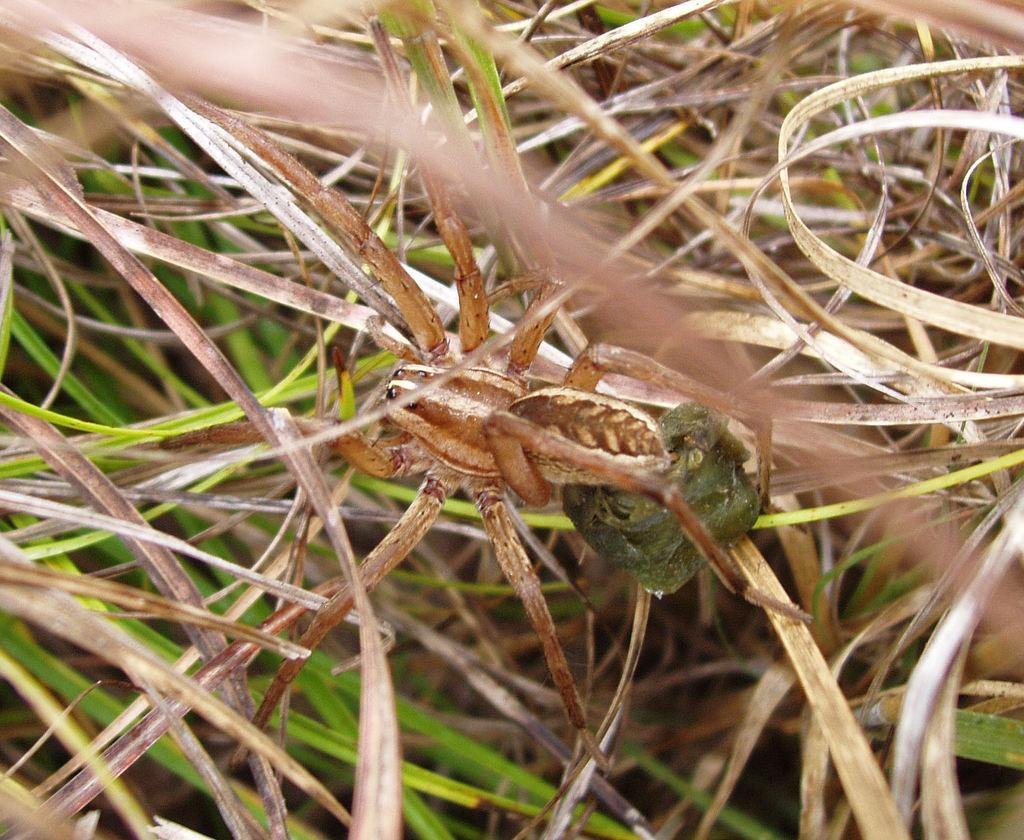What is the main subject in the middle of the image? There is a spider in the middle of the image. What can be seen in the background of the image? There are leaves of plants in the background of the image. What type of button does the spider use to communicate with its manager? There is no button or manager present in the image, as it features a spider and leaves of plants. 